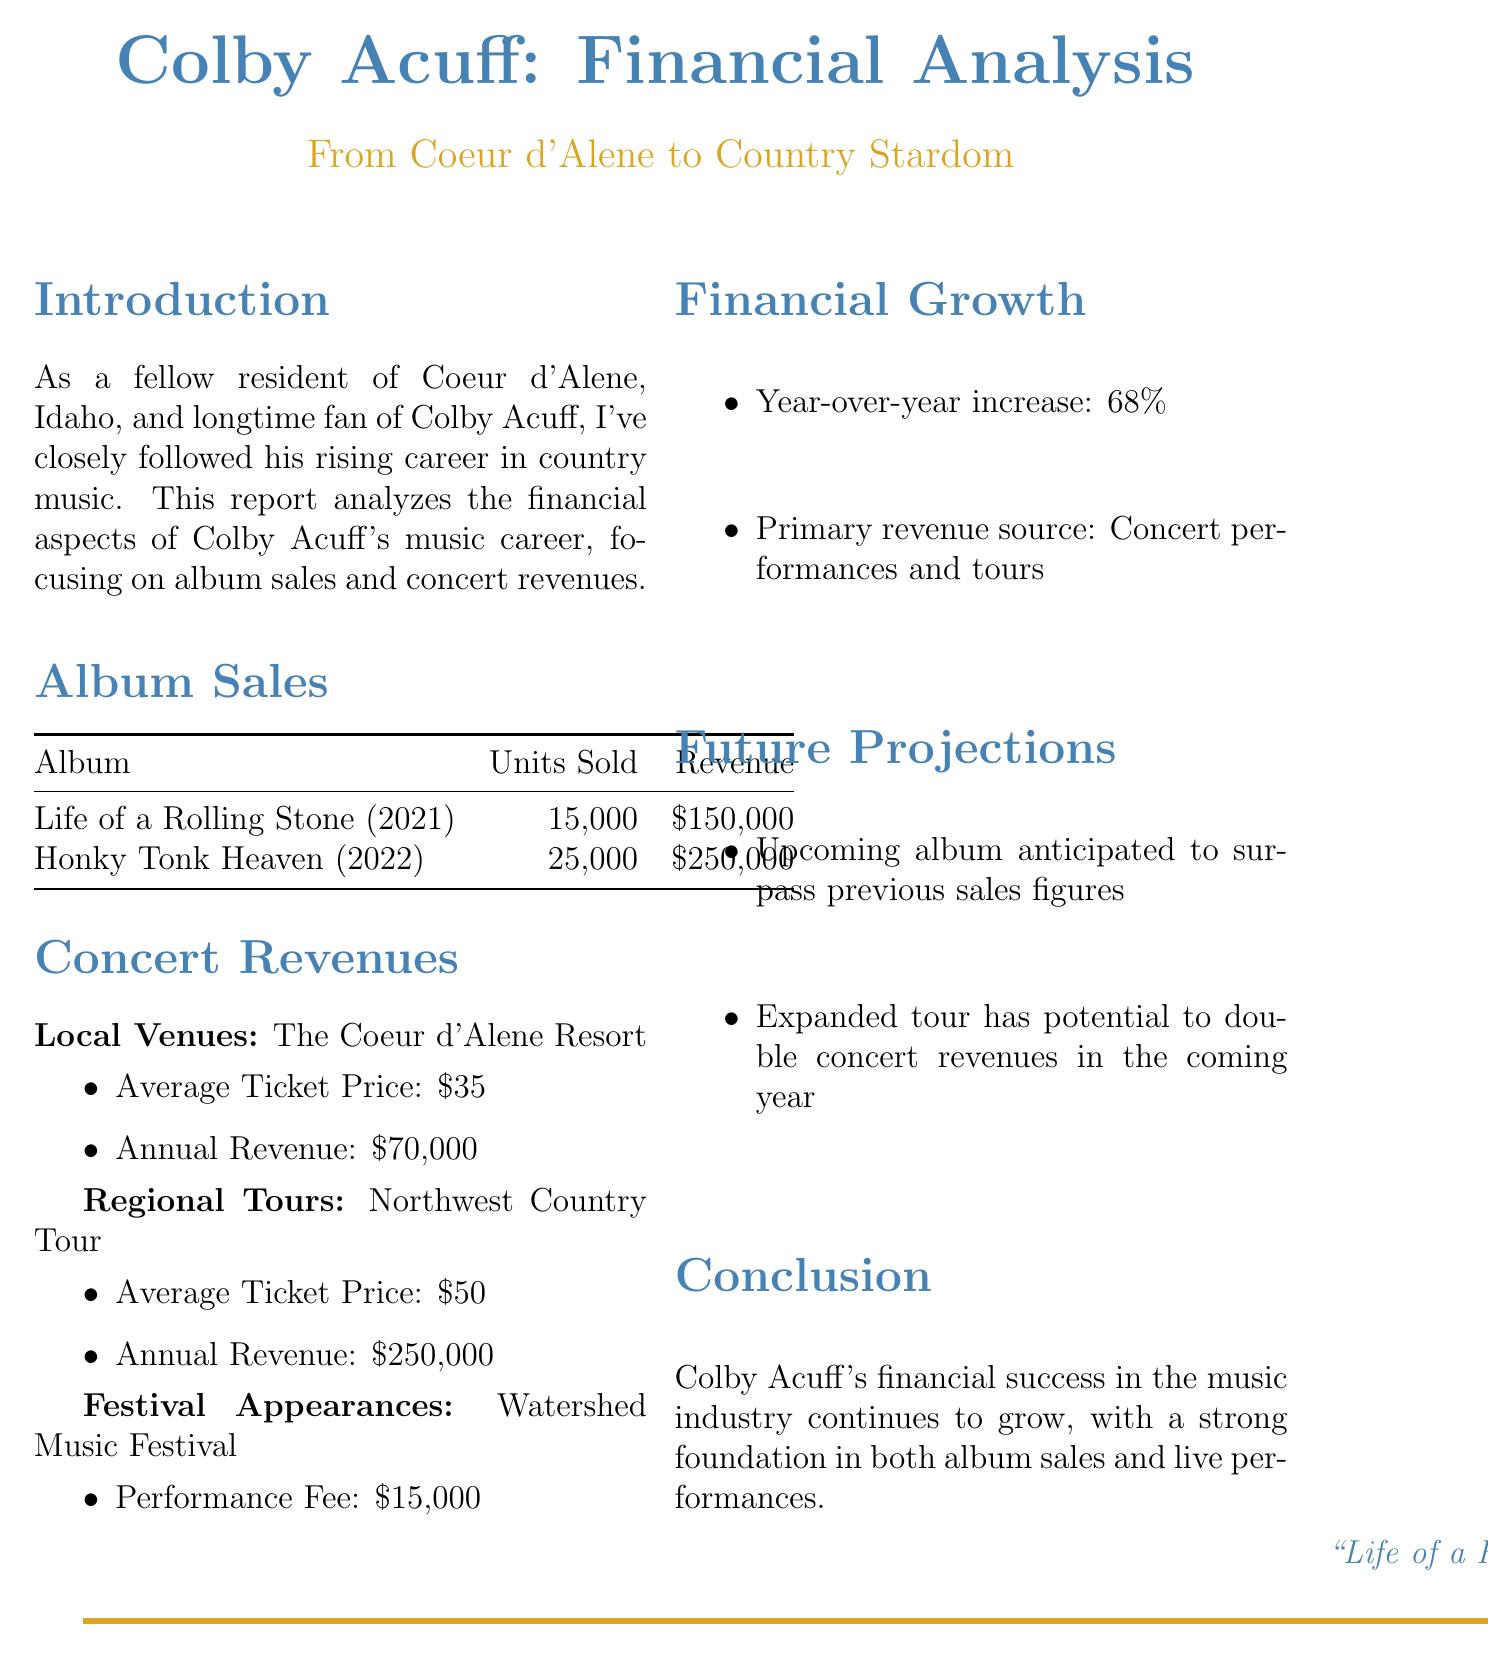What is the title of Colby Acuff's debut album? The title of Colby Acuff's debut album, according to the album sales section, is "Life of a Rolling Stone."
Answer: "Life of a Rolling Stone" How many units were sold of the sophomore album? The document states that the sophomore album, "Honky Tonk Heaven," sold 25,000 units.
Answer: 25000 What was the annual revenue from local venues? The financial report indicates that annual revenue from the Coeur d'Alene Resort is $70,000.
Answer: $70,000 What is the average ticket price for regional tours? The average ticket price for the Northwest Country Tour, a regional tour, is $50.
Answer: $50 What percentage increase does the financial growth section mention? The year-over-year increase in Colby Acuff's financial performance is stated as 68%.
Answer: 68% What is the performance fee for festival appearances? According to the document, the performance fee for the Watershed Music Festival is $15,000.
Answer: $15,000 Which is identified as the primary revenue source in the report? The document notes that the primary revenue source for Colby Acuff is concert performances and tours.
Answer: Concert performances and tours What is anticipated for the upcoming album? The report mentions that the upcoming album is anticipated to surpass previous sales figures.
Answer: Surpass previous sales figures How much revenue does the regional tour generate? The document states that the annual revenue from the Northwest Country Tour is $250,000.
Answer: $250,000 